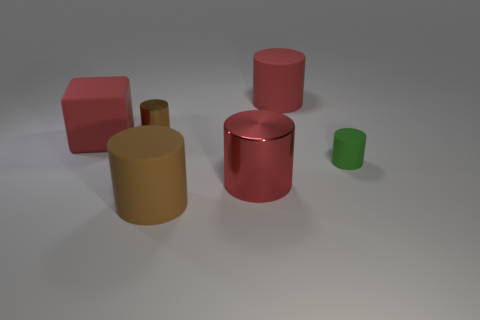Subtract all green cylinders. How many cylinders are left? 4 Add 4 large red metallic things. How many objects exist? 10 Subtract all big metal cylinders. How many cylinders are left? 4 Subtract all green cylinders. Subtract all yellow spheres. How many cylinders are left? 4 Subtract all blocks. How many objects are left? 5 Add 6 big red objects. How many big red objects are left? 9 Add 4 big red spheres. How many big red spheres exist? 4 Subtract 0 brown cubes. How many objects are left? 6 Subtract all big metal things. Subtract all cyan rubber cylinders. How many objects are left? 5 